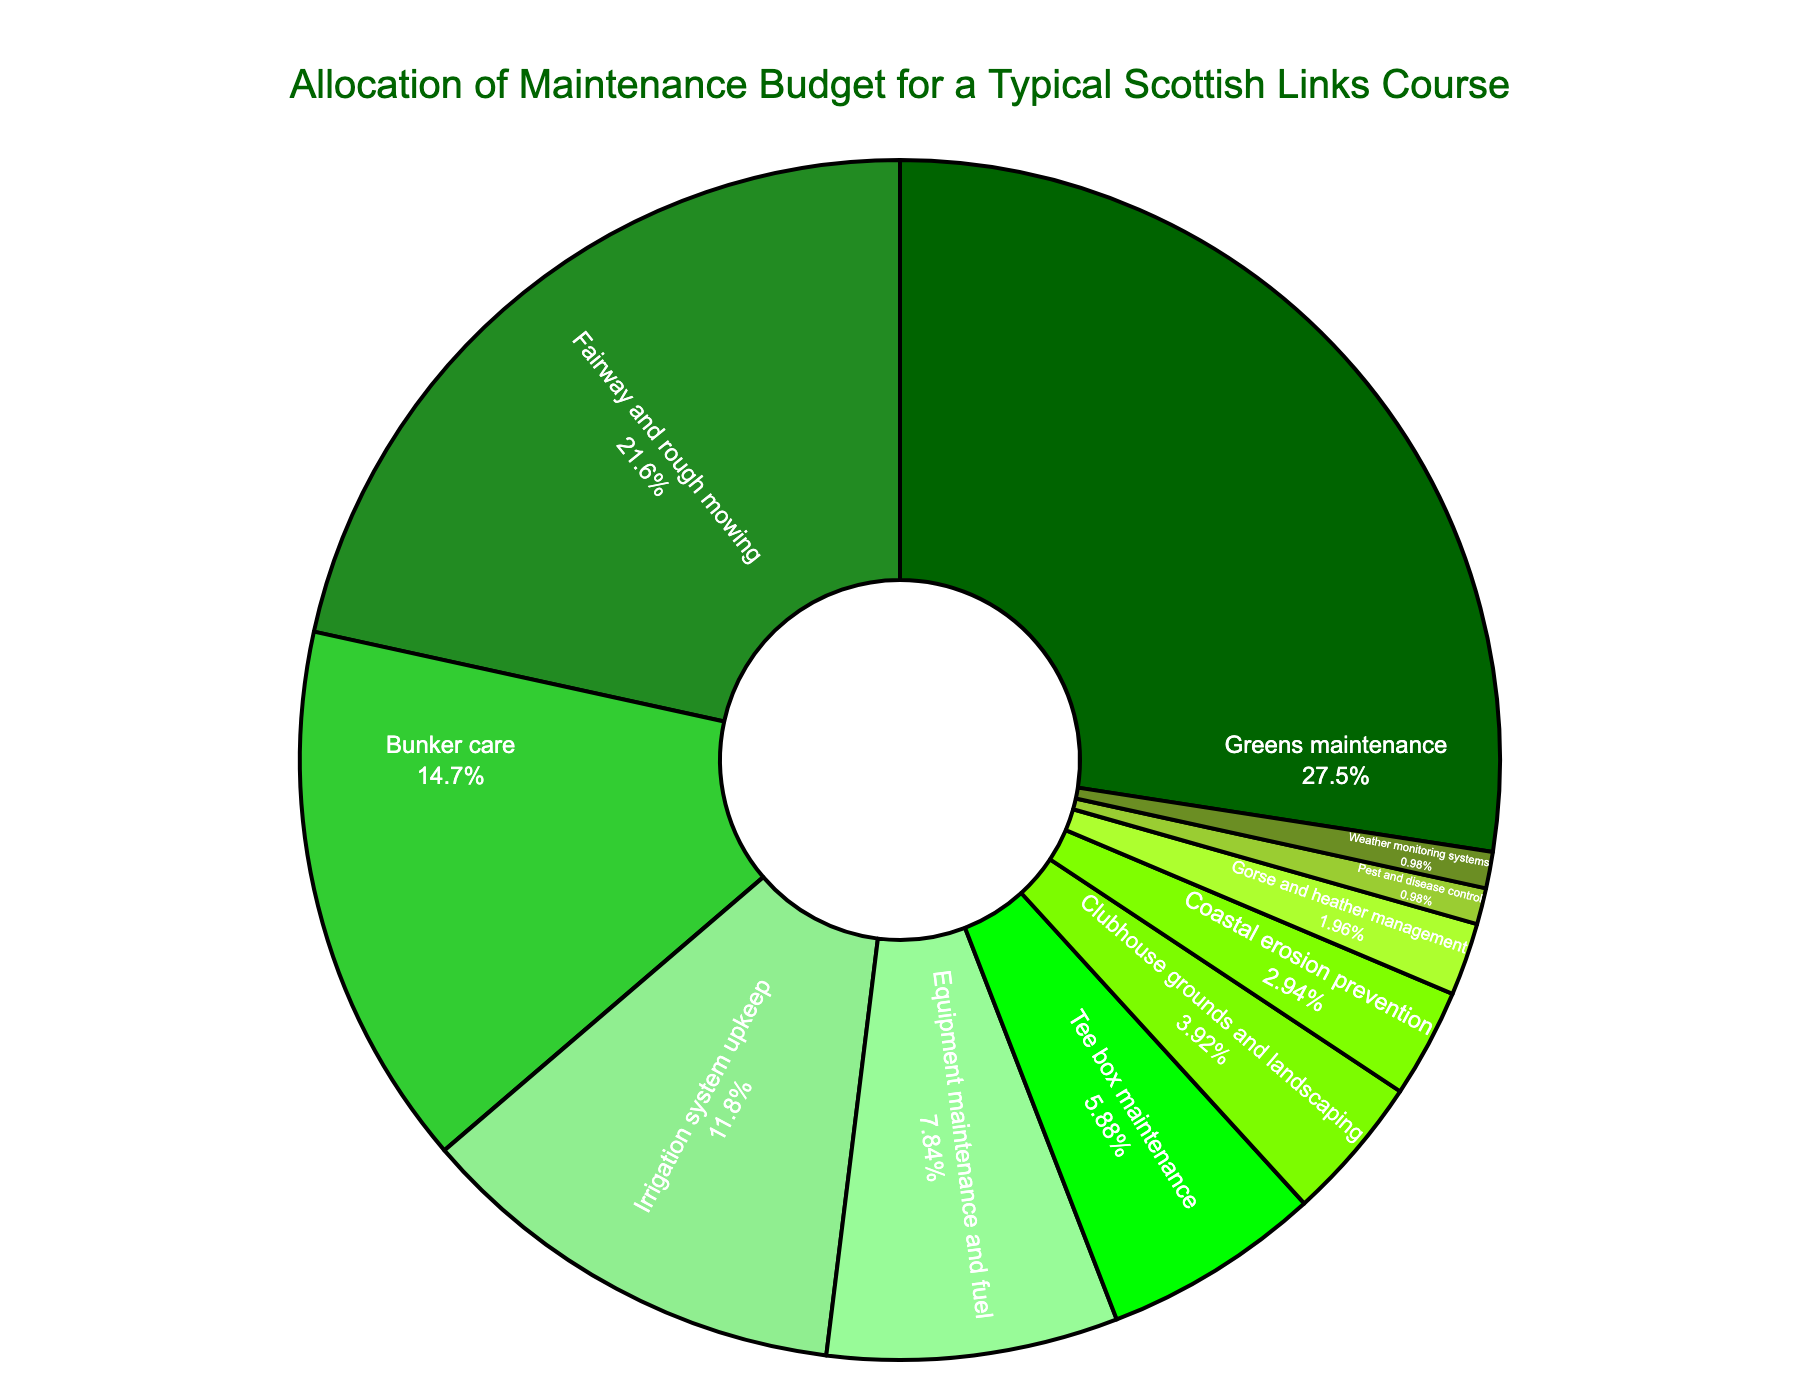Which maintenance category receives the highest percentage of the budget? The "Greens maintenance" category has the highest percentage at 28%, which is higher than any other category in the figure.
Answer: Greens maintenance What is the combined percentage of the budget allocated to "Fairway and rough mowing" and "Bunker care"? The percentage for "Fairway and rough mowing" is 22% and for "Bunker care" it is 15%. Adding these together, 22% + 15% = 37%.
Answer: 37% Is the percentage allocated to "Irrigation system upkeep" higher or lower than "Equipment maintenance and fuel"? The percentage for "Irrigation system upkeep" is 12%, and for "Equipment maintenance and fuel" it is 8%. Since 12% is greater than 8%, "Irrigation system upkeep" has a higher percentage.
Answer: Higher What is the total percentage of the budget allocated to "Clubhouse grounds and landscaping", "Coastal erosion prevention", and "Gorse and heather management"? The percentages are 4% for "Clubhouse grounds and landscaping", 3% for "Coastal erosion prevention", and 2% for "Gorse and heather management". Adding these, 4% + 3% + 2% = 9%.
Answer: 9% Which category receives exactly half the percentage of the budget allocated to "Greens maintenance"? "Greens maintenance" receives 28% of the budget. The category that receives exactly half of this (28% / 2 = 14%) is "Bunker care" with 15%, close to half.
Answer: Bunker care How much more budget percentage is allocated to "Greens maintenance" compared to "Gorse and heather management"? The difference between the percentages for "Greens maintenance" (28%) and "Gorse and heather management" (2%) is 28% - 2% = 26%.
Answer: 26% Which category has a lower percentage, "Tee box maintenance" or "Pest and disease control"? "Tee box maintenance" is allocated 6% of the budget, while "Pest and disease control" is allocated 1%. Since 1% is less than 6%, "Pest and disease control" has a lower percentage.
Answer: Pest and disease control What percentage of the budget is allocated to categories related to grounds and landscape (sum of "Greens maintenance", "Fairway and rough mowing", "Tee box maintenance", and "Clubhouse grounds and landscaping")? The respective percentages are 28%, 22%, 6%, and 4%. Summing these, 28% + 22% + 6% + 4% = 60%.
Answer: 60% Which maintenance category has the smallest allocation, and what is the percentage? The category "Weather monitoring systems" has the smallest allocation at 1%.
Answer: Weather monitoring systems, 1% How do the allocations for "Equipment maintenance and fuel" and "Greens maintenance" compare in terms of visual size in the pie chart? "Greens maintenance" slice is visually larger than the "Equipment maintenance and fuel" slice, reflecting a larger percentage (28% vs 8%).
Answer: Greens maintenance slice is larger 